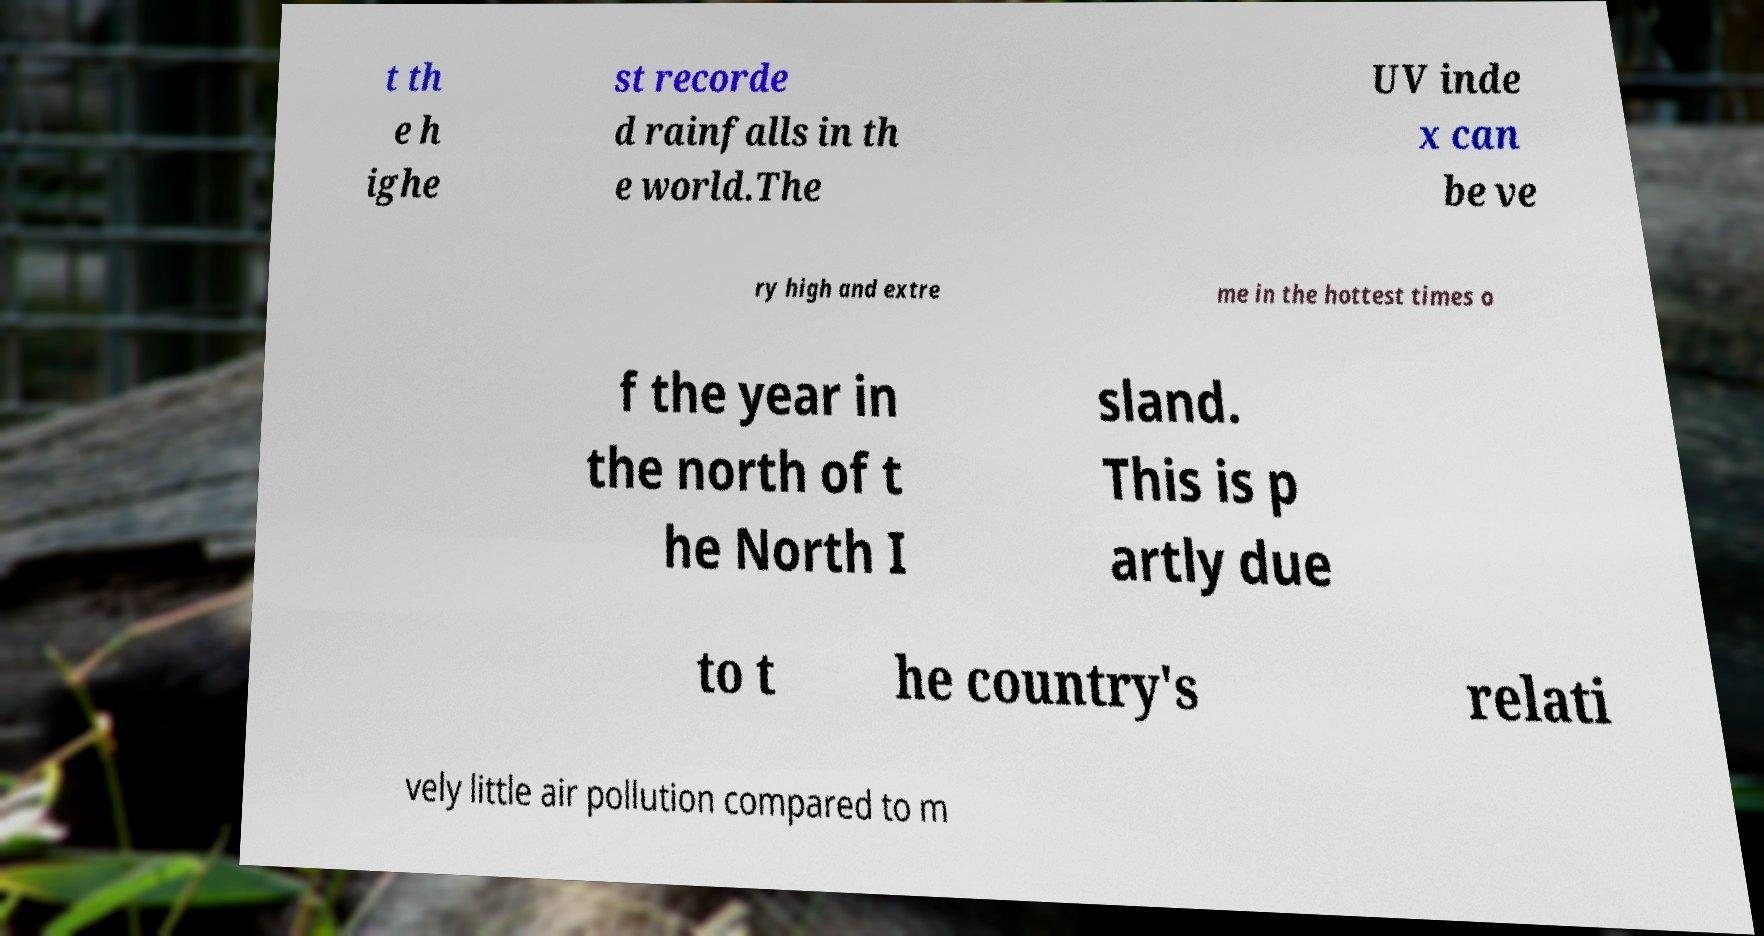For documentation purposes, I need the text within this image transcribed. Could you provide that? t th e h ighe st recorde d rainfalls in th e world.The UV inde x can be ve ry high and extre me in the hottest times o f the year in the north of t he North I sland. This is p artly due to t he country's relati vely little air pollution compared to m 